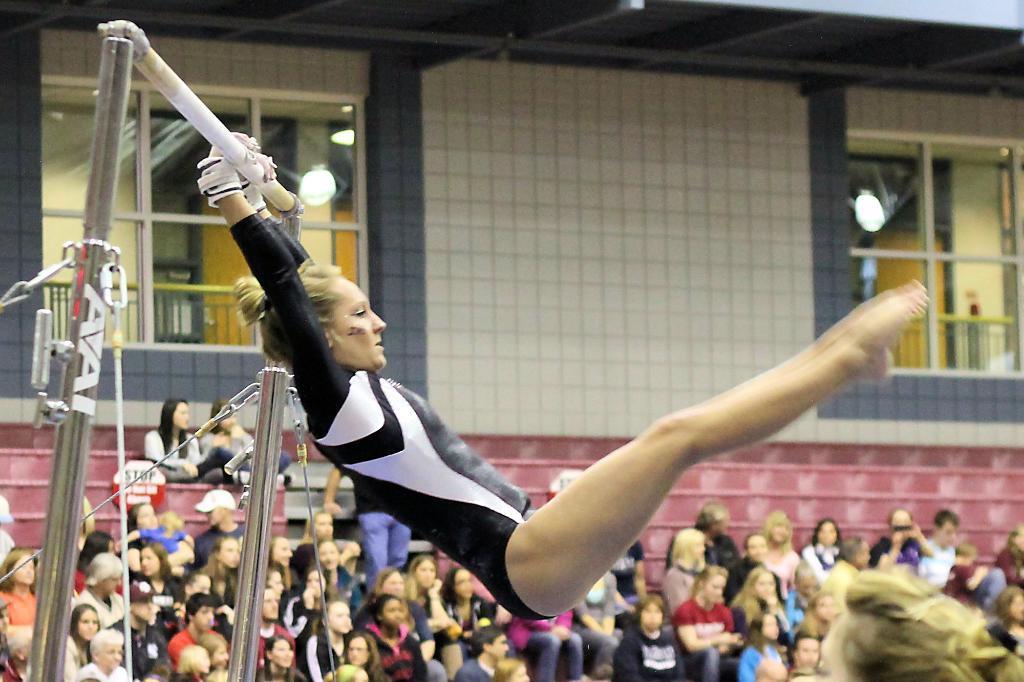Please provide a concise description of this image. In this image we can see a person wearing black color dress doing gymnastics holding some pole with her hands and at the background of the image there are some spectators sitting, there is wall and windows. 